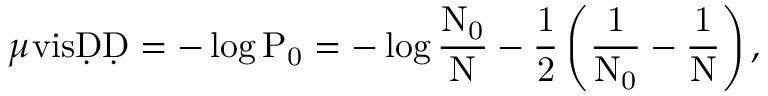<formula> <loc_0><loc_0><loc_500><loc_500>\mu v i s = - \log P _ { 0 } = - \log \frac { N _ { 0 } } { N } - \frac { 1 } { 2 } \left ( \frac { 1 } { N _ { 0 } } - \frac { 1 } { N } \right ) ,</formula> 